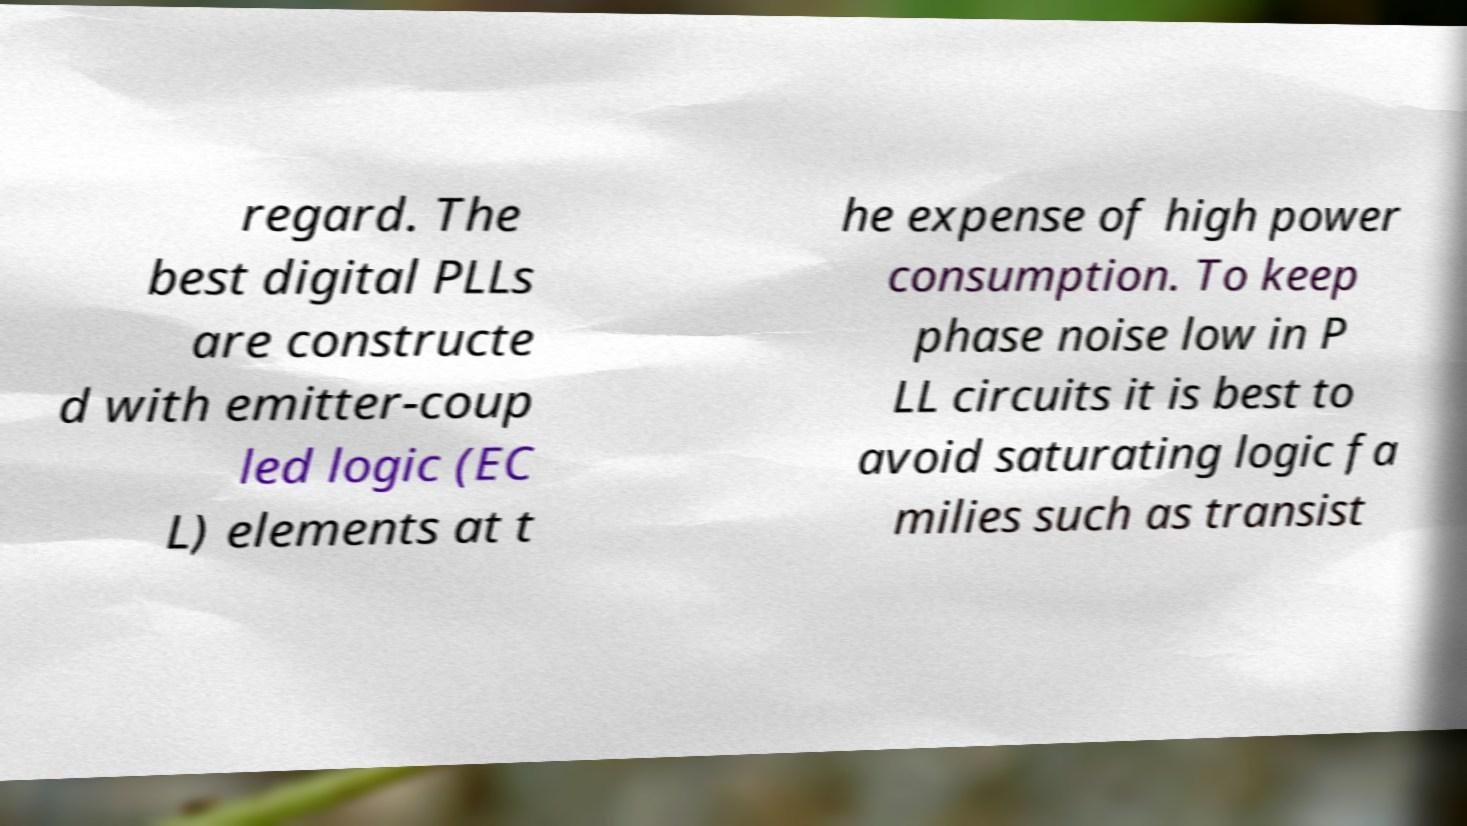For documentation purposes, I need the text within this image transcribed. Could you provide that? regard. The best digital PLLs are constructe d with emitter-coup led logic (EC L) elements at t he expense of high power consumption. To keep phase noise low in P LL circuits it is best to avoid saturating logic fa milies such as transist 